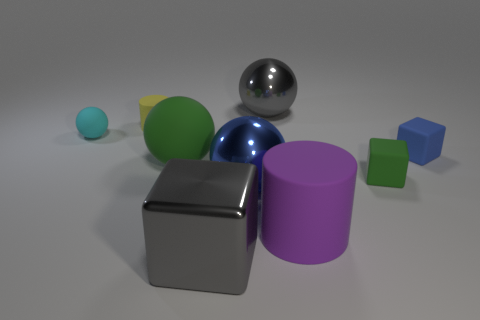Subtract all big spheres. How many spheres are left? 1 Subtract 1 blocks. How many blocks are left? 2 Subtract all gray balls. How many balls are left? 3 Subtract all purple spheres. Subtract all red cylinders. How many spheres are left? 4 Add 1 tiny yellow rubber cylinders. How many objects exist? 10 Subtract all cylinders. How many objects are left? 7 Subtract 1 green blocks. How many objects are left? 8 Subtract all big cylinders. Subtract all small yellow matte things. How many objects are left? 7 Add 4 small green rubber cubes. How many small green rubber cubes are left? 5 Add 3 small brown shiny cylinders. How many small brown shiny cylinders exist? 3 